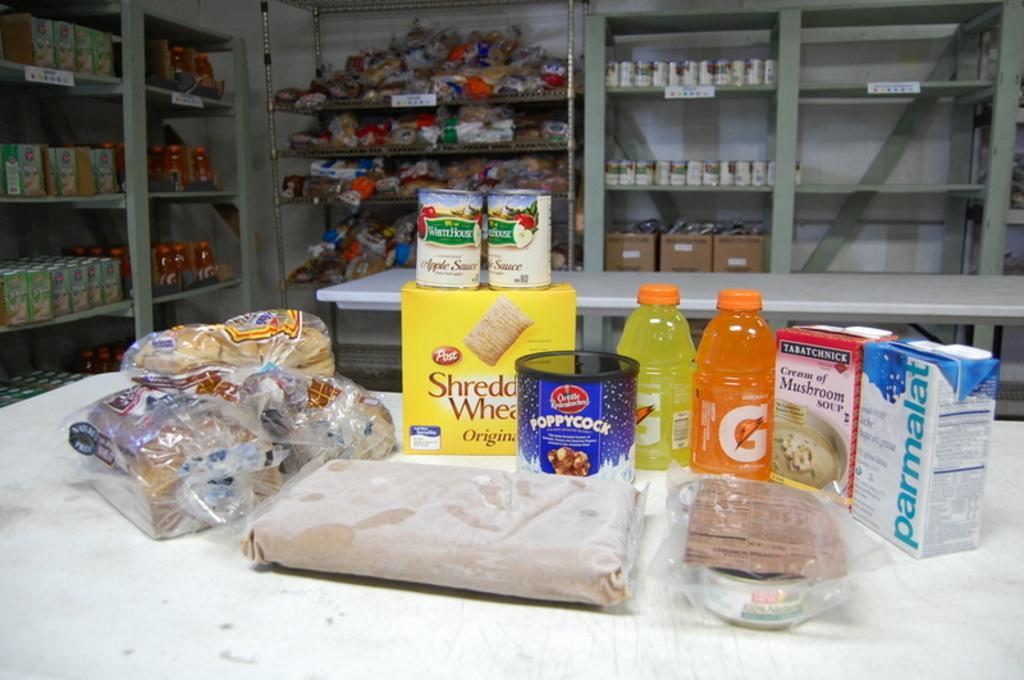<image>
Present a compact description of the photo's key features. a Gatorade bottle that is on a table 